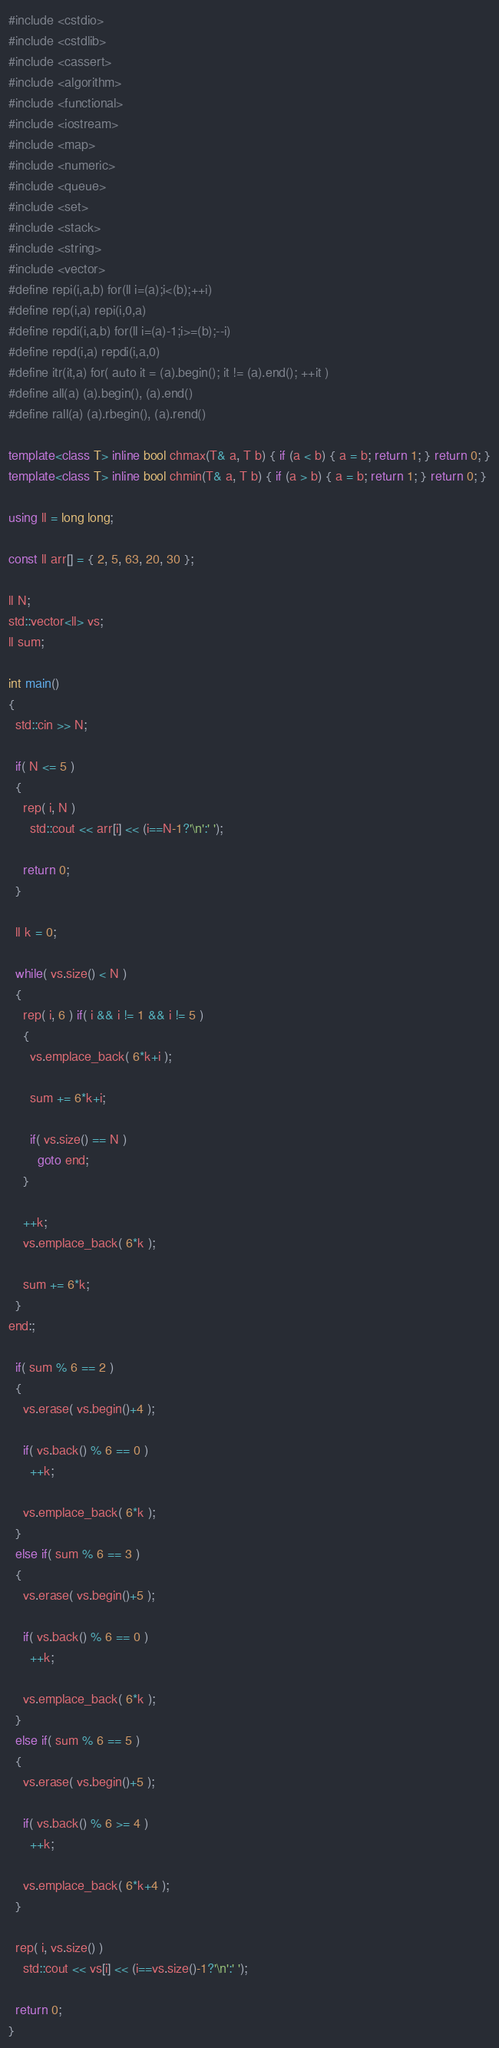<code> <loc_0><loc_0><loc_500><loc_500><_C++_>#include <cstdio>
#include <cstdlib>
#include <cassert>
#include <algorithm>
#include <functional>
#include <iostream>
#include <map>
#include <numeric>
#include <queue>
#include <set>
#include <stack>
#include <string>
#include <vector>
#define repi(i,a,b) for(ll i=(a);i<(b);++i)
#define rep(i,a) repi(i,0,a)
#define repdi(i,a,b) for(ll i=(a)-1;i>=(b);--i)
#define repd(i,a) repdi(i,a,0)
#define itr(it,a) for( auto it = (a).begin(); it != (a).end(); ++it )
#define all(a) (a).begin(), (a).end()
#define rall(a) (a).rbegin(), (a).rend()

template<class T> inline bool chmax(T& a, T b) { if (a < b) { a = b; return 1; } return 0; }
template<class T> inline bool chmin(T& a, T b) { if (a > b) { a = b; return 1; } return 0; }

using ll = long long;

const ll arr[] = { 2, 5, 63, 20, 30 };

ll N;
std::vector<ll> vs;
ll sum;

int main()
{
  std::cin >> N;

  if( N <= 5 )
  {
    rep( i, N )
      std::cout << arr[i] << (i==N-1?'\n':' ');

    return 0;
  }

  ll k = 0;
  
  while( vs.size() < N )
  {
    rep( i, 6 ) if( i && i != 1 && i != 5 )
    {
      vs.emplace_back( 6*k+i );

      sum += 6*k+i;

      if( vs.size() == N )
        goto end;
    } 

    ++k;
    vs.emplace_back( 6*k );

    sum += 6*k;
  }
end:;

  if( sum % 6 == 2 )
  {
    vs.erase( vs.begin()+4 );

    if( vs.back() % 6 == 0 )
      ++k;

    vs.emplace_back( 6*k );
  }
  else if( sum % 6 == 3 )
  {
    vs.erase( vs.begin()+5 );

    if( vs.back() % 6 == 0 )
      ++k;

    vs.emplace_back( 6*k );
  }
  else if( sum % 6 == 5 )
  {
    vs.erase( vs.begin()+5 );

    if( vs.back() % 6 >= 4 )
      ++k;

    vs.emplace_back( 6*k+4 );
  }

  rep( i, vs.size() )
    std::cout << vs[i] << (i==vs.size()-1?'\n':' ');

  return 0;
}</code> 